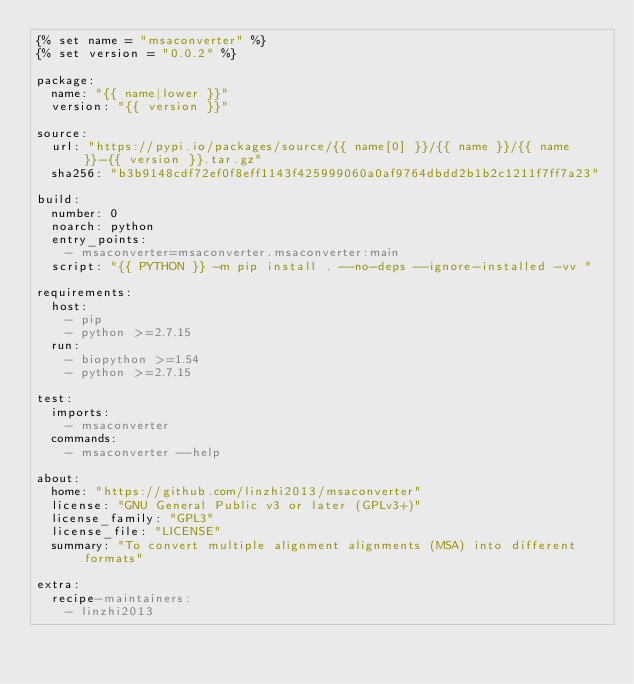Convert code to text. <code><loc_0><loc_0><loc_500><loc_500><_YAML_>{% set name = "msaconverter" %}
{% set version = "0.0.2" %}

package:
  name: "{{ name|lower }}"
  version: "{{ version }}"

source:
  url: "https://pypi.io/packages/source/{{ name[0] }}/{{ name }}/{{ name }}-{{ version }}.tar.gz"
  sha256: "b3b9148cdf72ef0f8eff1143f425999060a0af9764dbdd2b1b2c1211f7ff7a23"

build:
  number: 0
  noarch: python
  entry_points:
    - msaconverter=msaconverter.msaconverter:main
  script: "{{ PYTHON }} -m pip install . --no-deps --ignore-installed -vv "

requirements:
  host:
    - pip
    - python >=2.7.15
  run:
    - biopython >=1.54
    - python >=2.7.15

test:
  imports:
    - msaconverter
  commands:
    - msaconverter --help

about:
  home: "https://github.com/linzhi2013/msaconverter"
  license: "GNU General Public v3 or later (GPLv3+)"
  license_family: "GPL3"
  license_file: "LICENSE"
  summary: "To convert multiple alignment alignments (MSA) into different formats"

extra:
  recipe-maintainers:
    - linzhi2013
</code> 